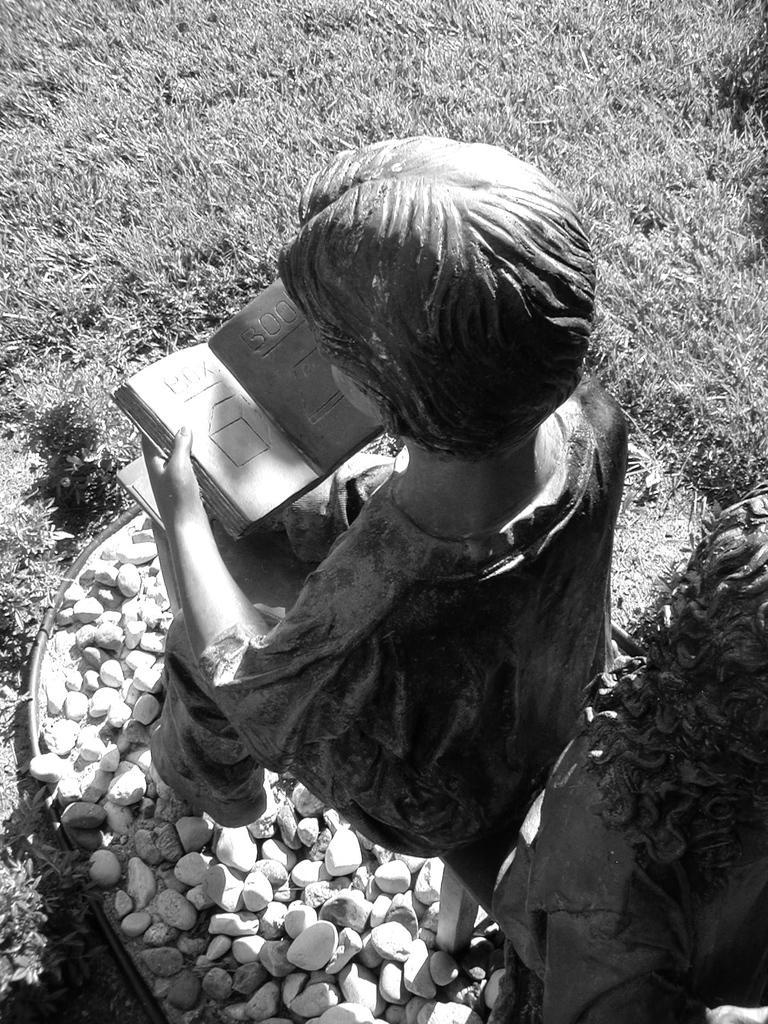Can you describe this image briefly? This is a black and white image. There is grass at the top. There is a statue in the middle. There are stones at the bottom. 